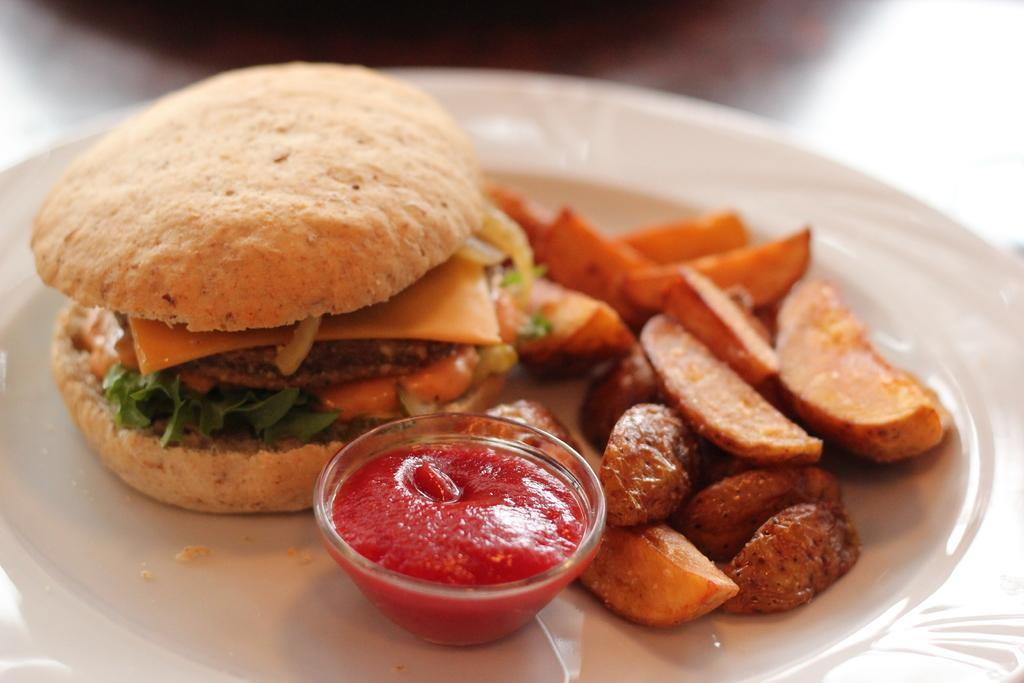What type of furniture is present in the image? There is a table in the picture. What is placed on the table in the image? There is a plate with a food item on the table. What else is on the plate in the image? There is a bowl with a food item on the plate. What type of stone is present in the image? There is no stone present in the image; the image features a table, a plate, and a bowl with food items. 